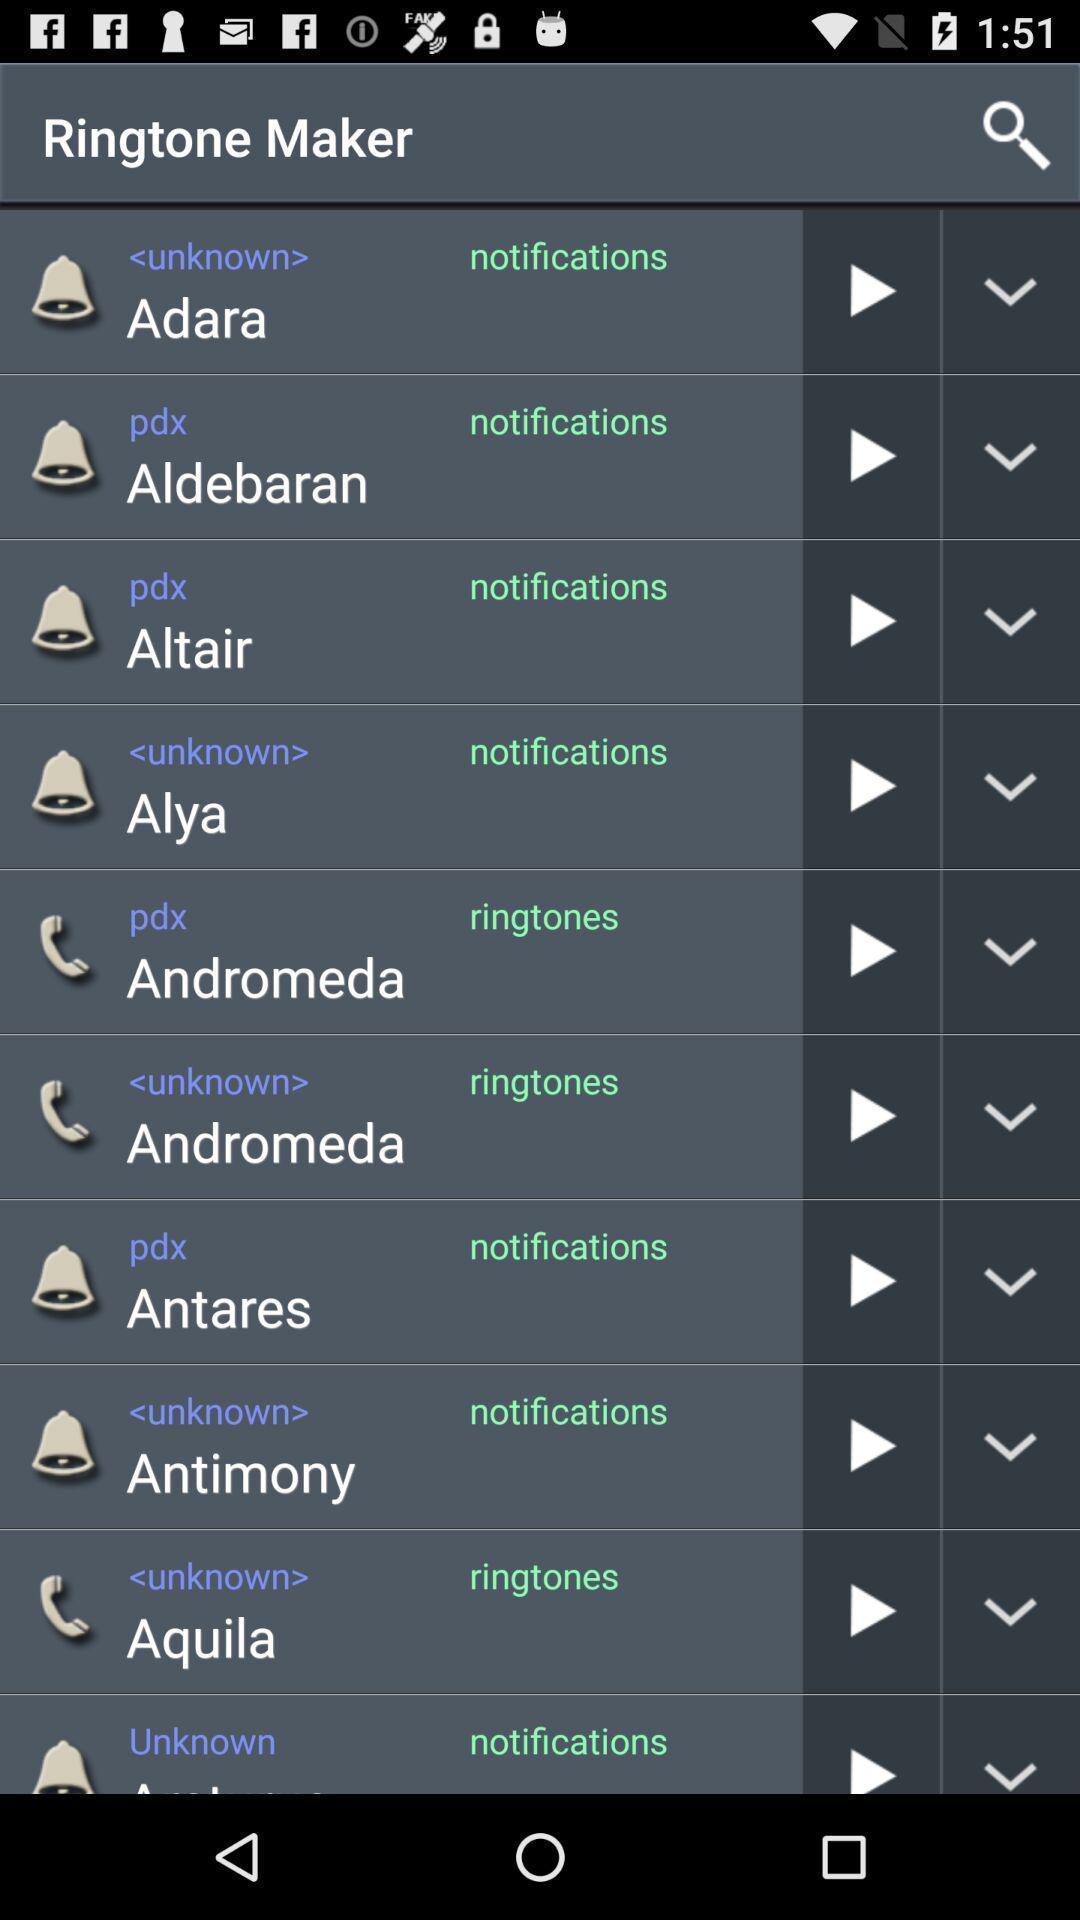Provide a description of this screenshot. Page displaying type of ringtones in audio editing app. 